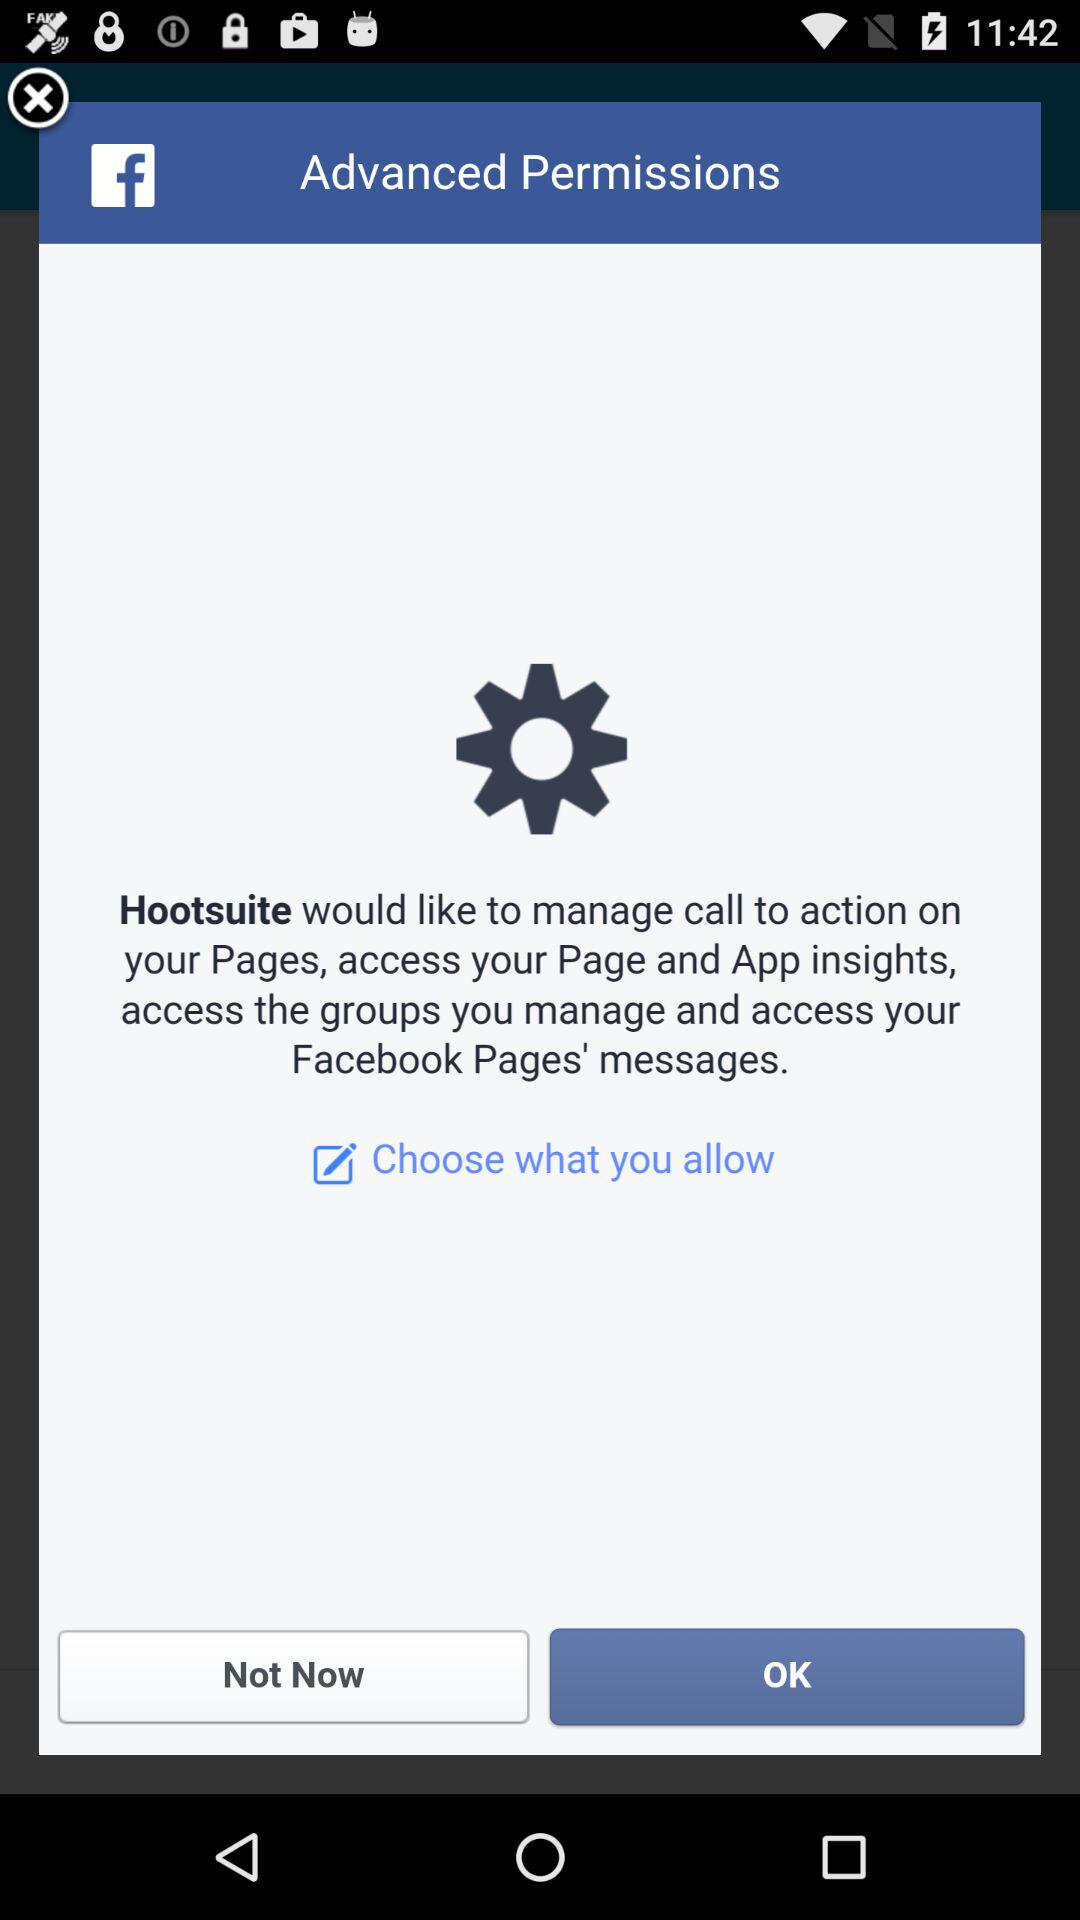What is the application name? The application names are "Hootsuite" and "Facebook". 